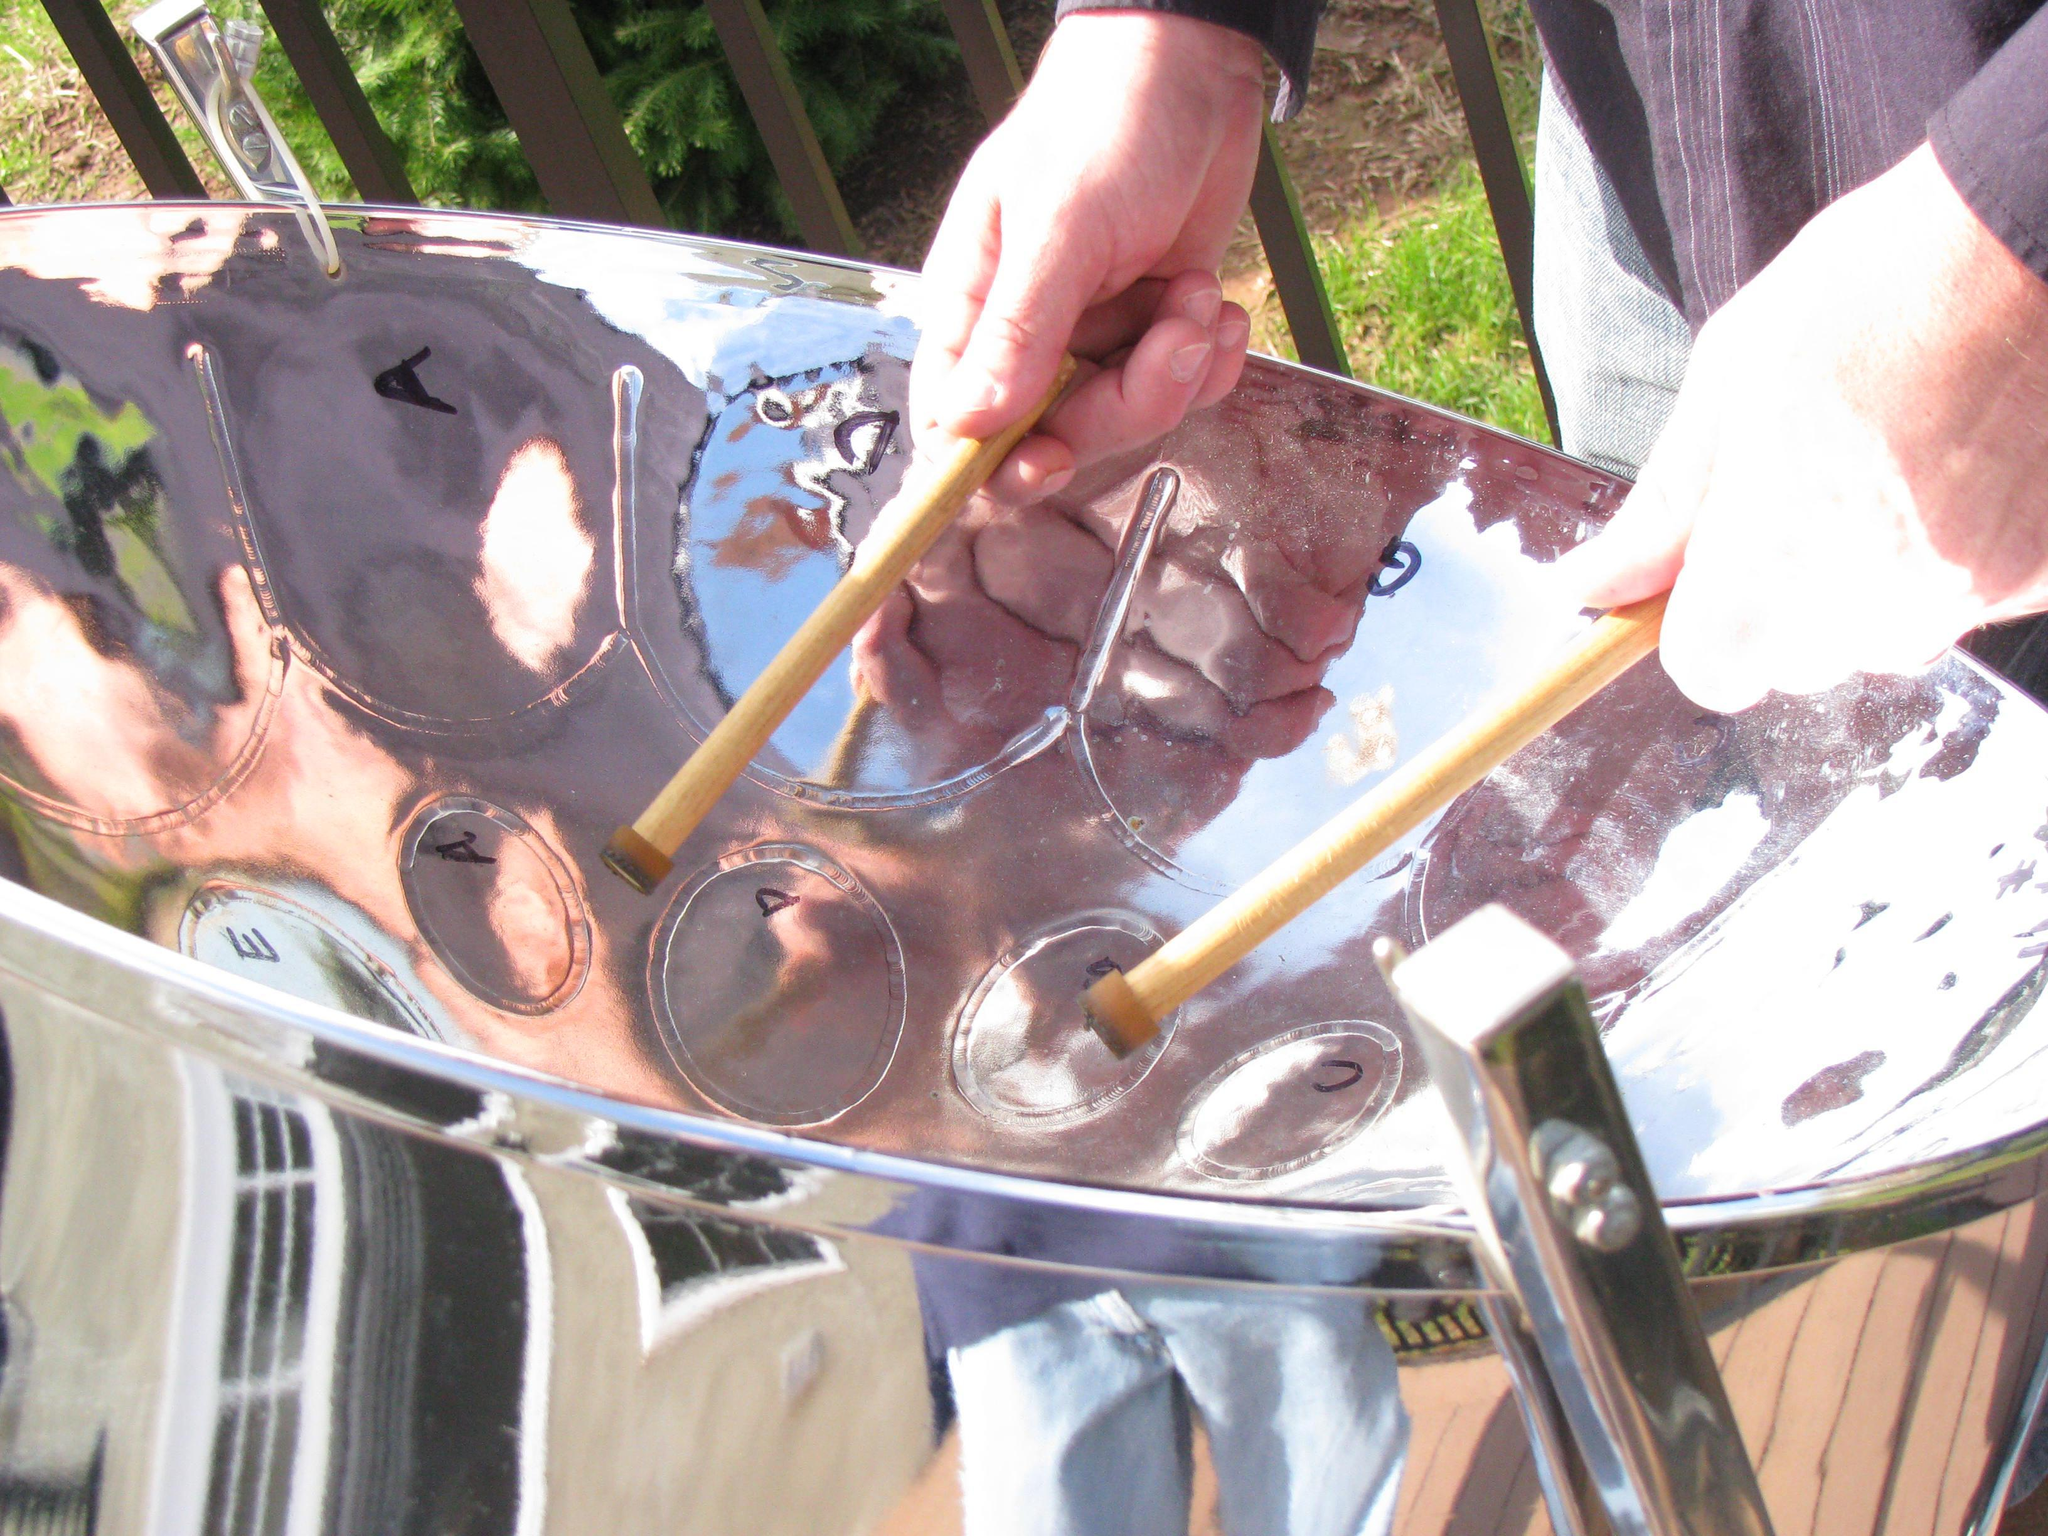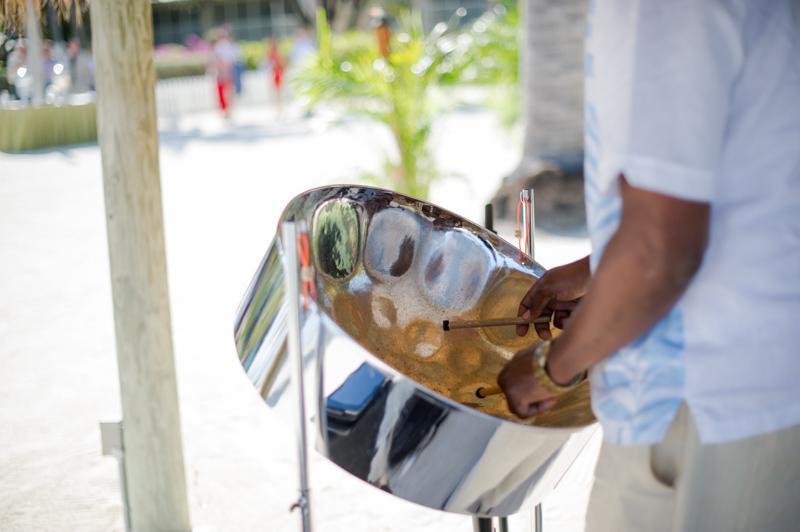The first image is the image on the left, the second image is the image on the right. Examine the images to the left and right. Is the description "One of these steel drums is not being played by a human right now." accurate? Answer yes or no. No. The first image is the image on the left, the second image is the image on the right. Given the left and right images, does the statement "Each image shows a pair of hands holding a pair of drumsticks inside the concave bowl of a silver drum." hold true? Answer yes or no. Yes. 